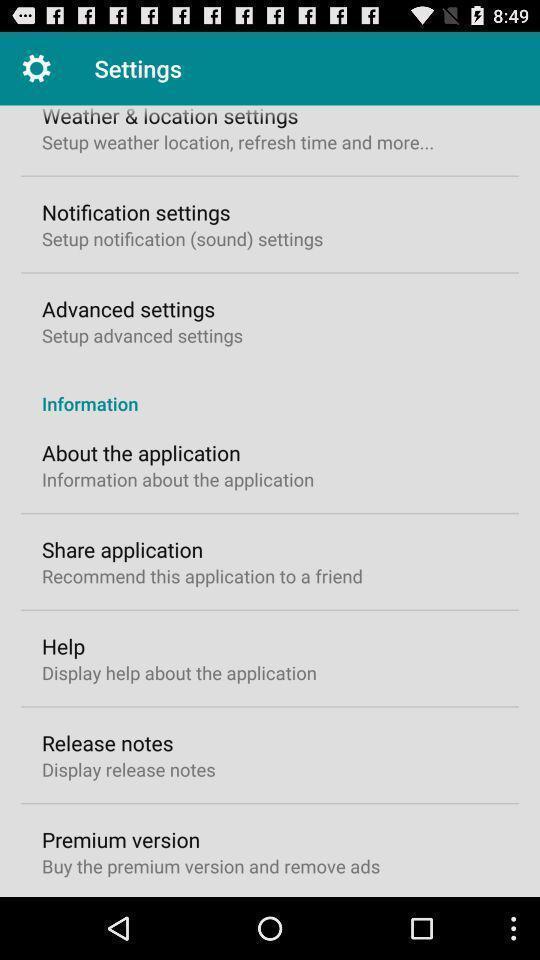Give me a narrative description of this picture. Settings page of weather forecast application. 